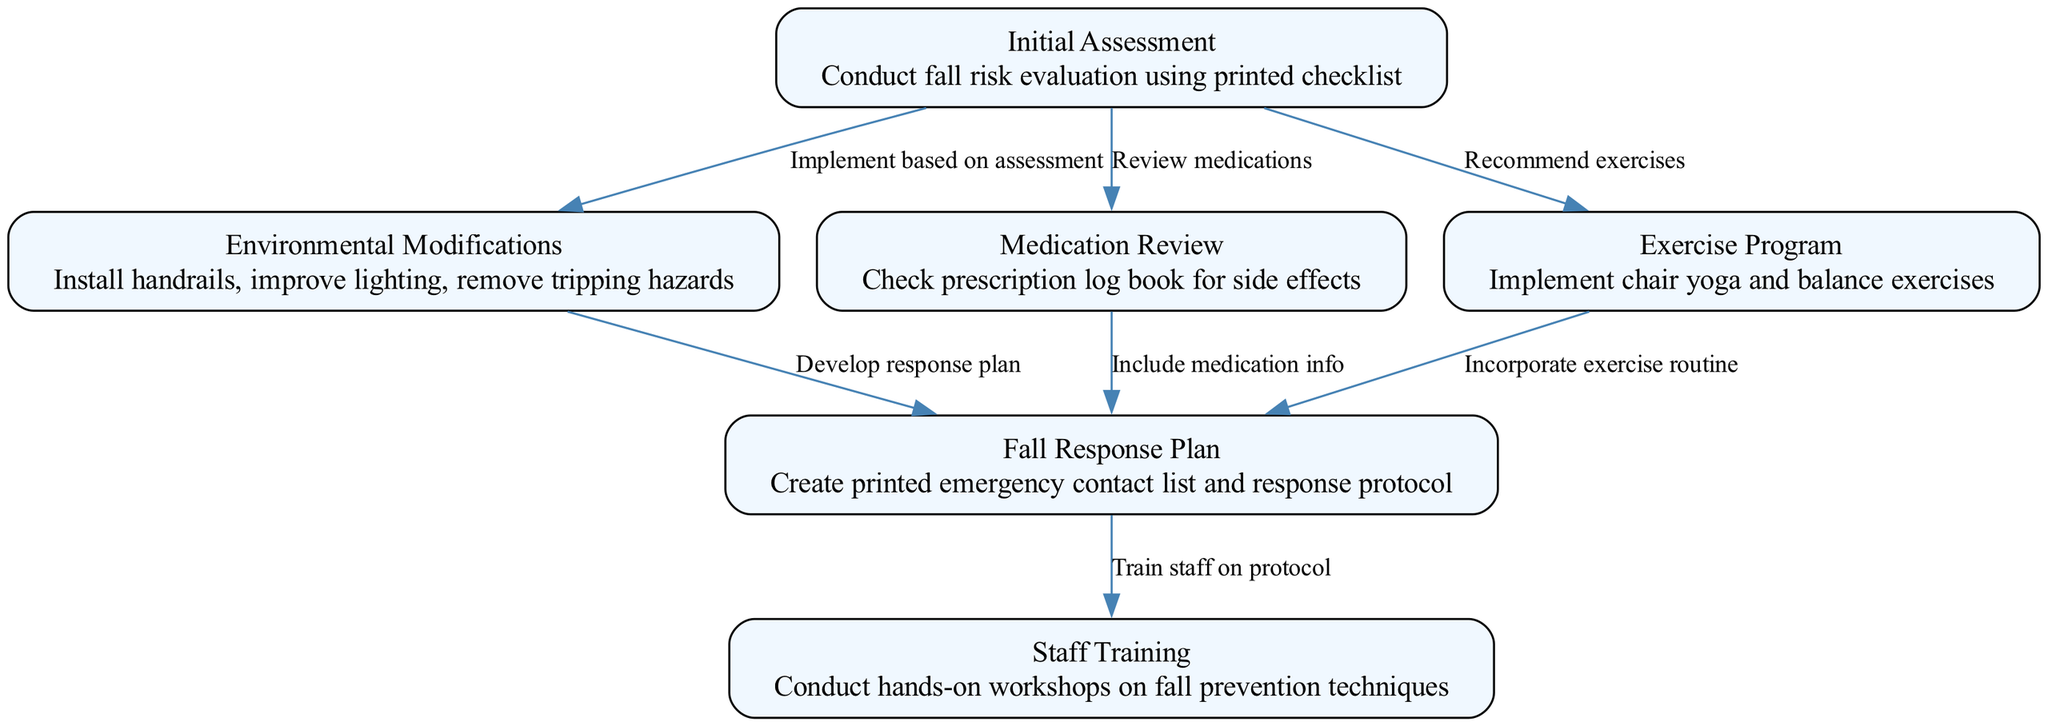What is the total number of nodes in the diagram? The diagram lists six distinct nodes: Initial Assessment, Environmental Modifications, Medication Review, Exercise Program, Fall Response Plan, and Staff Training. Therefore, the total count of nodes is six.
Answer: 6 What action is taken after the Initial Assessment? Following the Initial Assessment, three actions are indicated: Environmental Modifications, Medication Review, and Exercise Program. These nodes are all directly connected to the Initial Assessment node.
Answer: Environmental Modifications, Medication Review, Exercise Program Which node directly leads to Staff Training? The Staff Training node is connected directly from the Fall Response Plan node, showing that staff training occurs after the establishment of the response plan.
Answer: Fall Response Plan How many edges are connected to the Exercise Program node? The Exercise Program node is connected to one edge, which leads to the Fall Response Plan node. This indicates that the exercise program is incorporated into the response plan.
Answer: 1 What is included in the Fall Response Plan based on the connections? The Fall Response Plan incorporates information from Environmental Modifications, Medication Review, and Exercise Program nodes, indicating that these aspects are essential components of the response plan.
Answer: Environmental Modifications, Medication Review, Exercise Program What type of modifications is recommended in the Environmental Modifications node? The Environmental Modifications node details specific recommendations, including installing handrails, improving lighting, and removing tripping hazards to prevent falls.
Answer: Install handrails, improve lighting, remove tripping hazards 